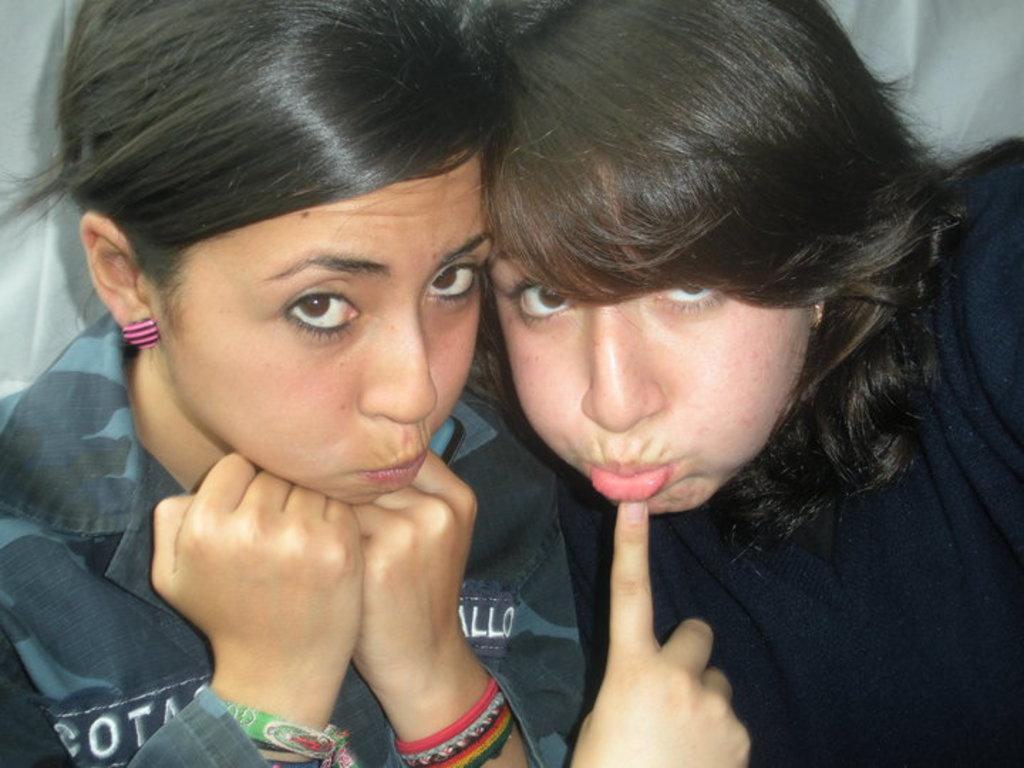How many people are in the image? There are two girls in the image. Where are the girls located in the image? The girls are in the foreground of the image. What are the girls doing in the image? The girls are doing some kind of expression. What type of plastic material can be seen in the image? There is no plastic material present in the image. What is the girls' role in leading the group in the image? The image does not depict a group or any leadership role for the girls. 